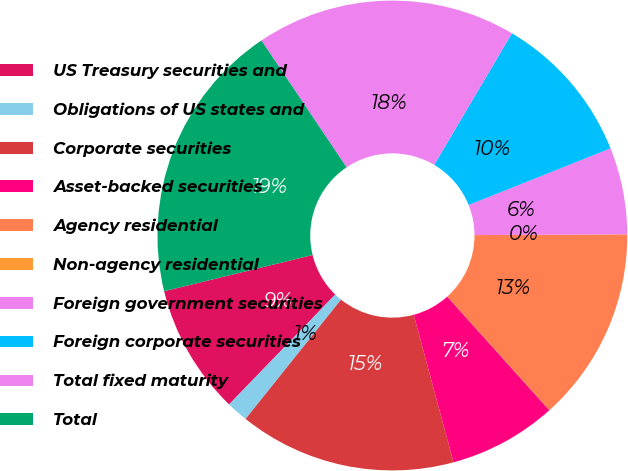Convert chart. <chart><loc_0><loc_0><loc_500><loc_500><pie_chart><fcel>US Treasury securities and<fcel>Obligations of US states and<fcel>Corporate securities<fcel>Asset-backed securities<fcel>Agency residential<fcel>Non-agency residential<fcel>Foreign government securities<fcel>Foreign corporate securities<fcel>Total fixed maturity<fcel>Total<nl><fcel>8.96%<fcel>1.49%<fcel>14.93%<fcel>7.46%<fcel>13.43%<fcel>0.0%<fcel>5.97%<fcel>10.45%<fcel>17.91%<fcel>19.4%<nl></chart> 